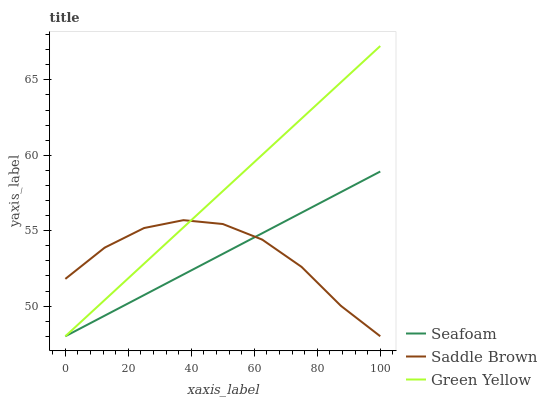Does Saddle Brown have the minimum area under the curve?
Answer yes or no. Yes. Does Green Yellow have the maximum area under the curve?
Answer yes or no. Yes. Does Seafoam have the minimum area under the curve?
Answer yes or no. No. Does Seafoam have the maximum area under the curve?
Answer yes or no. No. Is Seafoam the smoothest?
Answer yes or no. Yes. Is Saddle Brown the roughest?
Answer yes or no. Yes. Is Saddle Brown the smoothest?
Answer yes or no. No. Is Seafoam the roughest?
Answer yes or no. No. Does Green Yellow have the lowest value?
Answer yes or no. Yes. Does Green Yellow have the highest value?
Answer yes or no. Yes. Does Seafoam have the highest value?
Answer yes or no. No. Does Saddle Brown intersect Seafoam?
Answer yes or no. Yes. Is Saddle Brown less than Seafoam?
Answer yes or no. No. Is Saddle Brown greater than Seafoam?
Answer yes or no. No. 